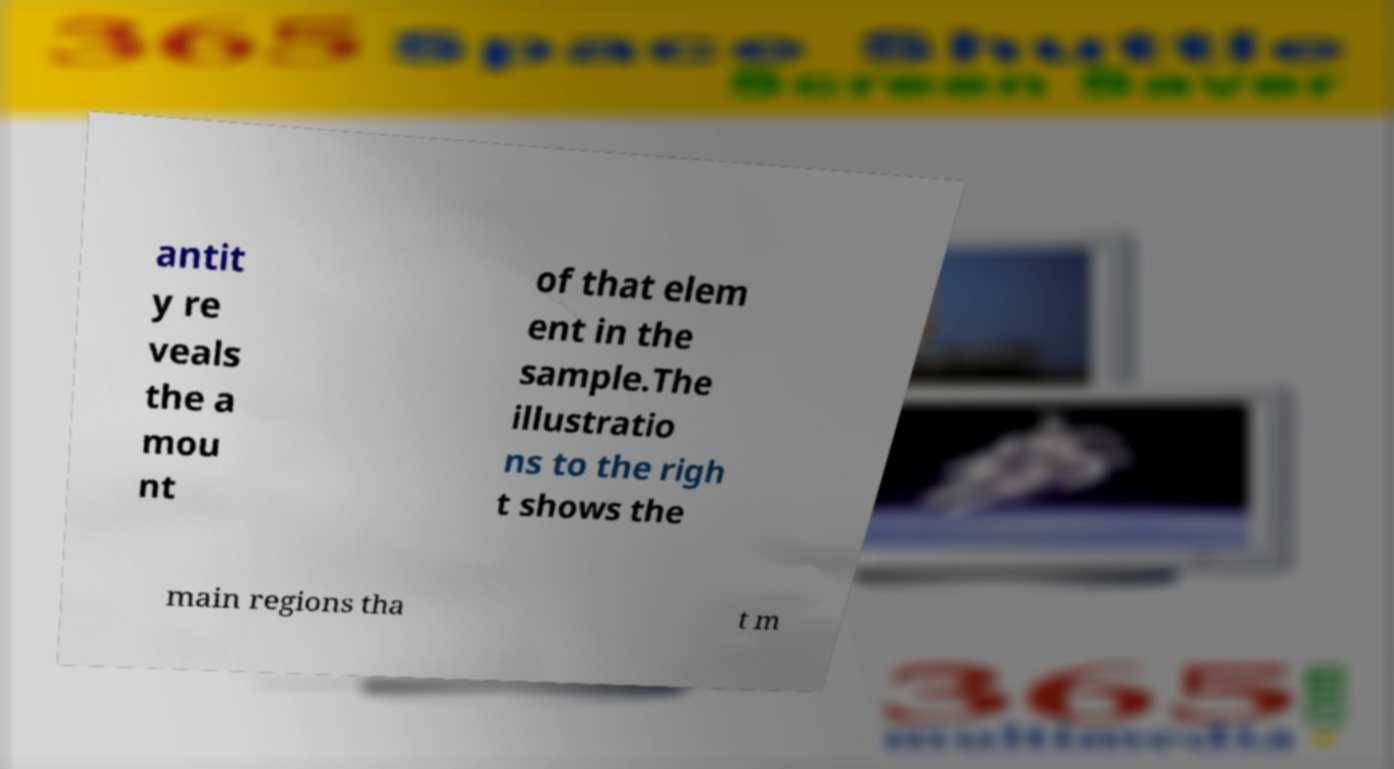Please identify and transcribe the text found in this image. antit y re veals the a mou nt of that elem ent in the sample.The illustratio ns to the righ t shows the main regions tha t m 